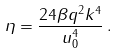<formula> <loc_0><loc_0><loc_500><loc_500>\eta = \frac { 2 4 \beta q ^ { 2 } k ^ { 4 } } { u _ { 0 } ^ { 4 } } \, .</formula> 